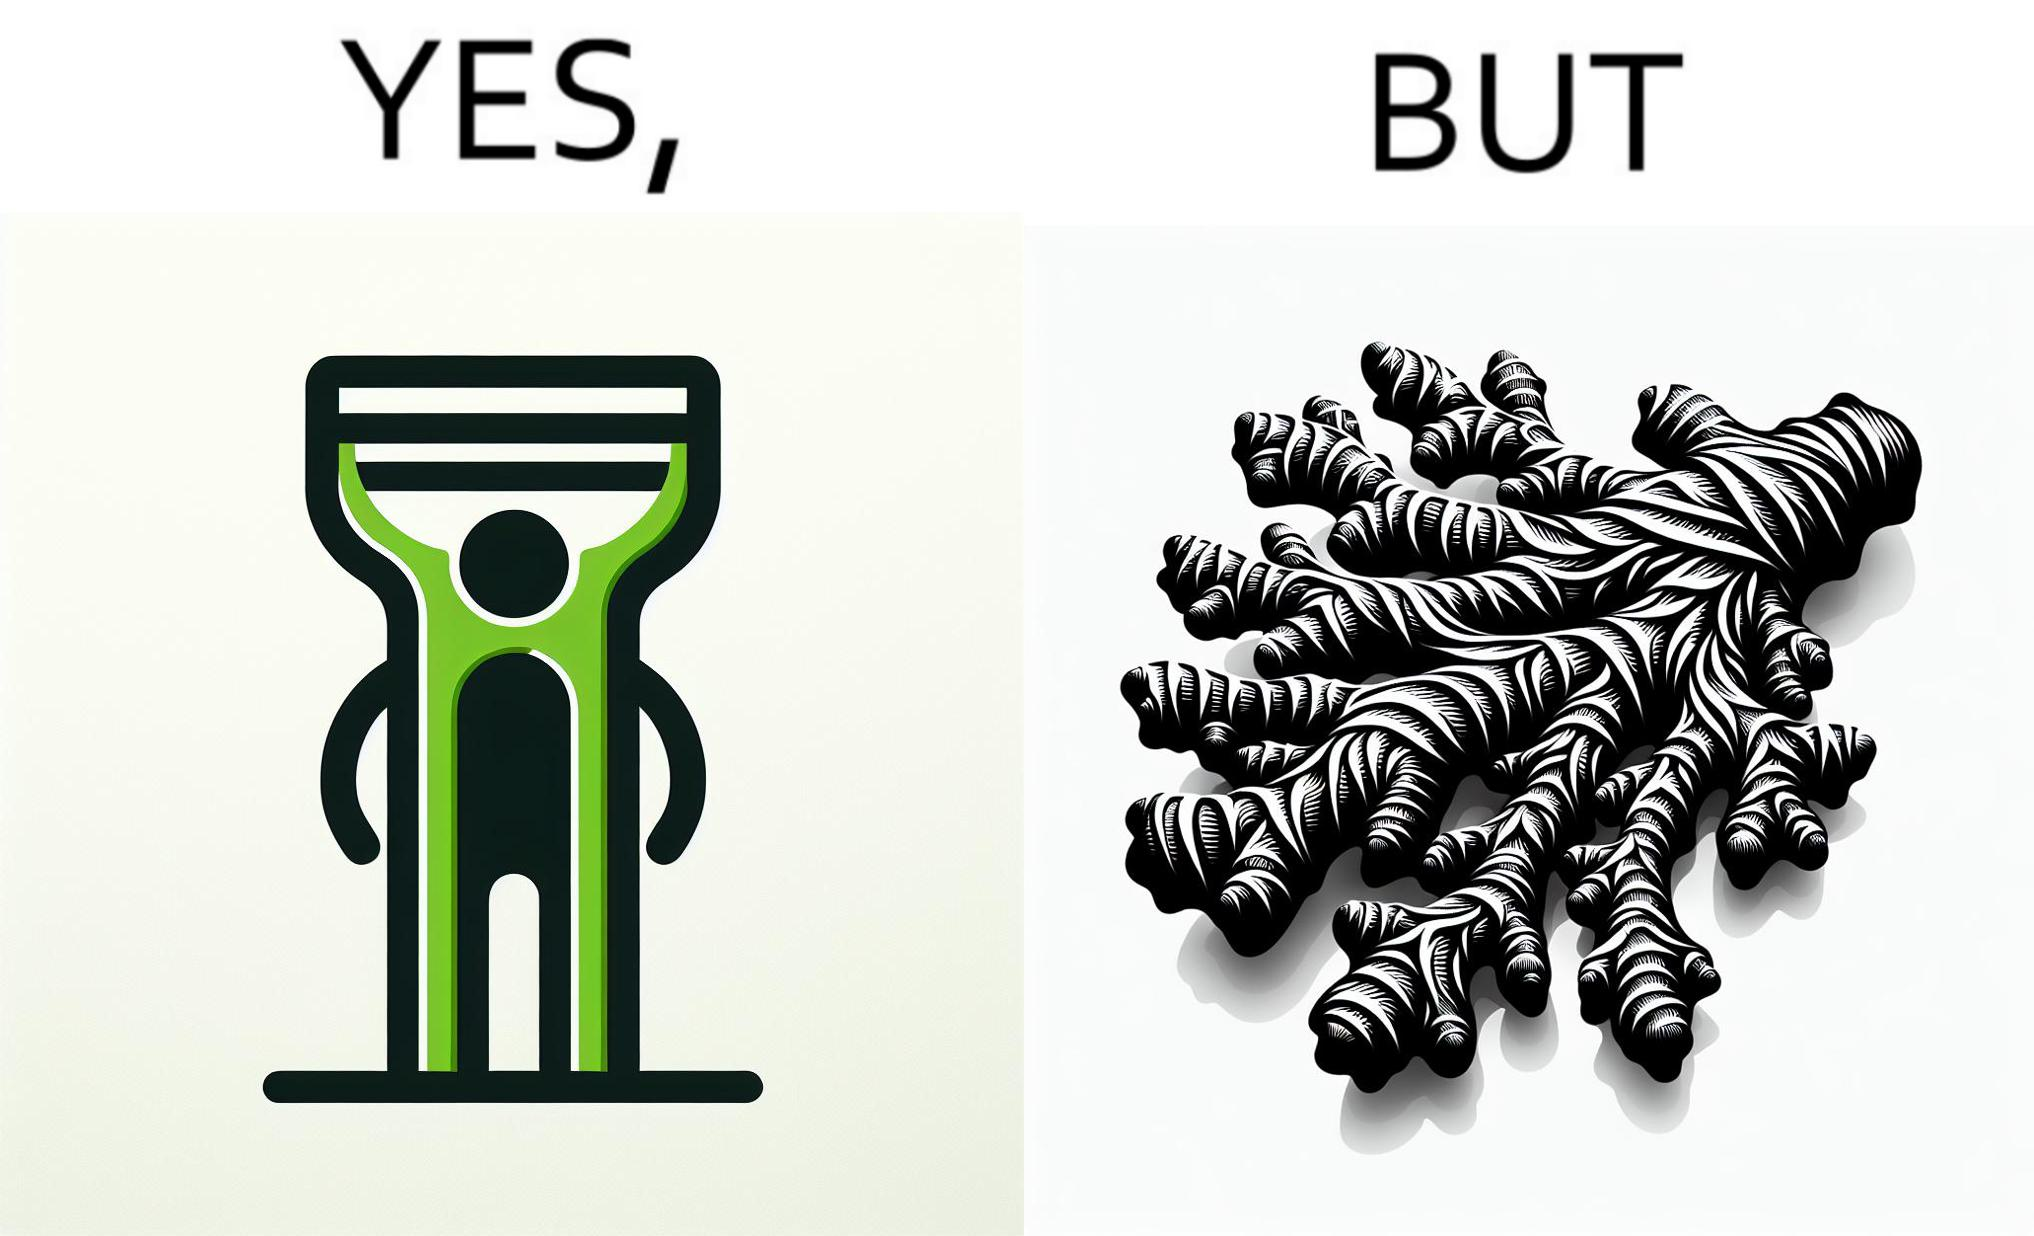Is this a satirical image? Yes, this image is satirical. 